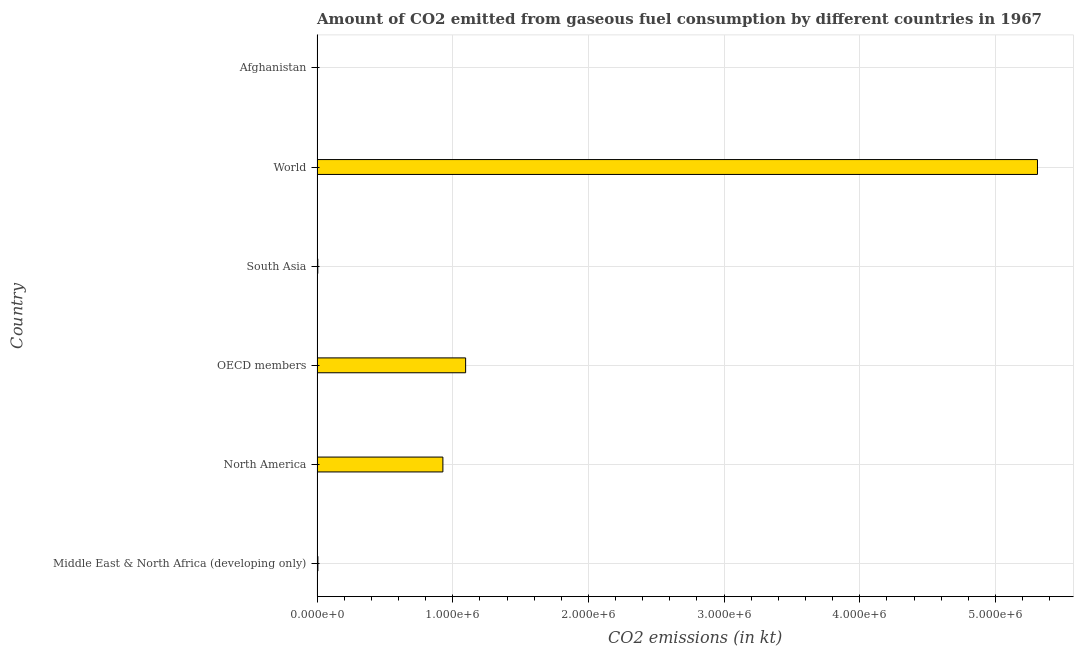Does the graph contain grids?
Provide a succinct answer. Yes. What is the title of the graph?
Give a very brief answer. Amount of CO2 emitted from gaseous fuel consumption by different countries in 1967. What is the label or title of the X-axis?
Make the answer very short. CO2 emissions (in kt). What is the co2 emissions from gaseous fuel consumption in Afghanistan?
Your answer should be compact. 260.36. Across all countries, what is the maximum co2 emissions from gaseous fuel consumption?
Your answer should be very brief. 5.31e+06. Across all countries, what is the minimum co2 emissions from gaseous fuel consumption?
Ensure brevity in your answer.  260.36. In which country was the co2 emissions from gaseous fuel consumption maximum?
Make the answer very short. World. In which country was the co2 emissions from gaseous fuel consumption minimum?
Ensure brevity in your answer.  Afghanistan. What is the sum of the co2 emissions from gaseous fuel consumption?
Make the answer very short. 7.34e+06. What is the difference between the co2 emissions from gaseous fuel consumption in Middle East & North Africa (developing only) and South Asia?
Ensure brevity in your answer.  878.63. What is the average co2 emissions from gaseous fuel consumption per country?
Ensure brevity in your answer.  1.22e+06. What is the median co2 emissions from gaseous fuel consumption?
Offer a terse response. 4.67e+05. What is the ratio of the co2 emissions from gaseous fuel consumption in Afghanistan to that in Middle East & North Africa (developing only)?
Make the answer very short. 0.04. Is the co2 emissions from gaseous fuel consumption in Afghanistan less than that in OECD members?
Your answer should be very brief. Yes. Is the difference between the co2 emissions from gaseous fuel consumption in Middle East & North Africa (developing only) and North America greater than the difference between any two countries?
Make the answer very short. No. What is the difference between the highest and the second highest co2 emissions from gaseous fuel consumption?
Your response must be concise. 4.21e+06. Is the sum of the co2 emissions from gaseous fuel consumption in Afghanistan and South Asia greater than the maximum co2 emissions from gaseous fuel consumption across all countries?
Your answer should be very brief. No. What is the difference between the highest and the lowest co2 emissions from gaseous fuel consumption?
Ensure brevity in your answer.  5.31e+06. In how many countries, is the co2 emissions from gaseous fuel consumption greater than the average co2 emissions from gaseous fuel consumption taken over all countries?
Offer a terse response. 1. Are all the bars in the graph horizontal?
Make the answer very short. Yes. What is the difference between two consecutive major ticks on the X-axis?
Your answer should be very brief. 1.00e+06. What is the CO2 emissions (in kt) of Middle East & North Africa (developing only)?
Your response must be concise. 6347.35. What is the CO2 emissions (in kt) in North America?
Offer a very short reply. 9.27e+05. What is the CO2 emissions (in kt) of OECD members?
Provide a short and direct response. 1.10e+06. What is the CO2 emissions (in kt) of South Asia?
Keep it short and to the point. 5468.72. What is the CO2 emissions (in kt) in World?
Ensure brevity in your answer.  5.31e+06. What is the CO2 emissions (in kt) in Afghanistan?
Ensure brevity in your answer.  260.36. What is the difference between the CO2 emissions (in kt) in Middle East & North Africa (developing only) and North America?
Your response must be concise. -9.21e+05. What is the difference between the CO2 emissions (in kt) in Middle East & North Africa (developing only) and OECD members?
Keep it short and to the point. -1.09e+06. What is the difference between the CO2 emissions (in kt) in Middle East & North Africa (developing only) and South Asia?
Ensure brevity in your answer.  878.63. What is the difference between the CO2 emissions (in kt) in Middle East & North Africa (developing only) and World?
Your response must be concise. -5.30e+06. What is the difference between the CO2 emissions (in kt) in Middle East & North Africa (developing only) and Afghanistan?
Your answer should be compact. 6086.99. What is the difference between the CO2 emissions (in kt) in North America and OECD members?
Your answer should be compact. -1.68e+05. What is the difference between the CO2 emissions (in kt) in North America and South Asia?
Make the answer very short. 9.22e+05. What is the difference between the CO2 emissions (in kt) in North America and World?
Offer a terse response. -4.38e+06. What is the difference between the CO2 emissions (in kt) in North America and Afghanistan?
Offer a very short reply. 9.27e+05. What is the difference between the CO2 emissions (in kt) in OECD members and South Asia?
Give a very brief answer. 1.09e+06. What is the difference between the CO2 emissions (in kt) in OECD members and World?
Provide a succinct answer. -4.21e+06. What is the difference between the CO2 emissions (in kt) in OECD members and Afghanistan?
Provide a short and direct response. 1.09e+06. What is the difference between the CO2 emissions (in kt) in South Asia and World?
Give a very brief answer. -5.30e+06. What is the difference between the CO2 emissions (in kt) in South Asia and Afghanistan?
Make the answer very short. 5208.37. What is the difference between the CO2 emissions (in kt) in World and Afghanistan?
Keep it short and to the point. 5.31e+06. What is the ratio of the CO2 emissions (in kt) in Middle East & North Africa (developing only) to that in North America?
Make the answer very short. 0.01. What is the ratio of the CO2 emissions (in kt) in Middle East & North Africa (developing only) to that in OECD members?
Your answer should be compact. 0.01. What is the ratio of the CO2 emissions (in kt) in Middle East & North Africa (developing only) to that in South Asia?
Provide a succinct answer. 1.16. What is the ratio of the CO2 emissions (in kt) in Middle East & North Africa (developing only) to that in Afghanistan?
Provide a succinct answer. 24.38. What is the ratio of the CO2 emissions (in kt) in North America to that in OECD members?
Offer a terse response. 0.85. What is the ratio of the CO2 emissions (in kt) in North America to that in South Asia?
Keep it short and to the point. 169.6. What is the ratio of the CO2 emissions (in kt) in North America to that in World?
Ensure brevity in your answer.  0.17. What is the ratio of the CO2 emissions (in kt) in North America to that in Afghanistan?
Your answer should be compact. 3562.39. What is the ratio of the CO2 emissions (in kt) in OECD members to that in South Asia?
Give a very brief answer. 200.24. What is the ratio of the CO2 emissions (in kt) in OECD members to that in World?
Make the answer very short. 0.21. What is the ratio of the CO2 emissions (in kt) in OECD members to that in Afghanistan?
Offer a terse response. 4205.88. What is the ratio of the CO2 emissions (in kt) in South Asia to that in World?
Provide a short and direct response. 0. What is the ratio of the CO2 emissions (in kt) in South Asia to that in Afghanistan?
Offer a terse response. 21. What is the ratio of the CO2 emissions (in kt) in World to that in Afghanistan?
Your answer should be very brief. 2.04e+04. 